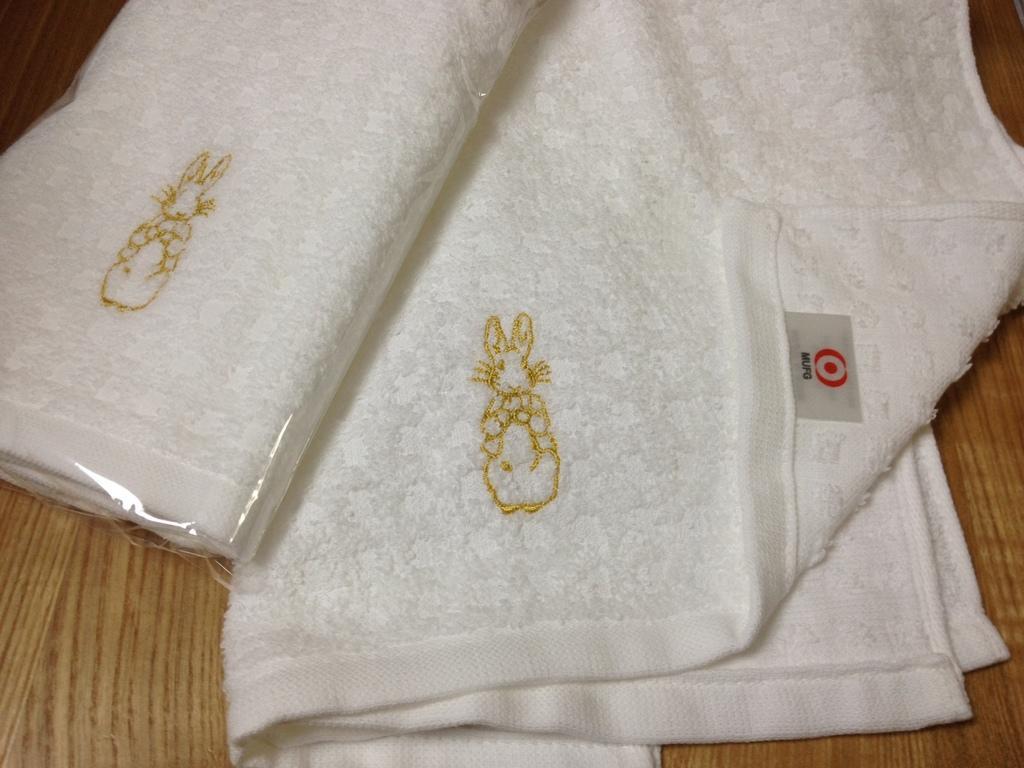Could you give a brief overview of what you see in this image? In this picture we can see white color clothes and we can find embroidery work on the clothes. 